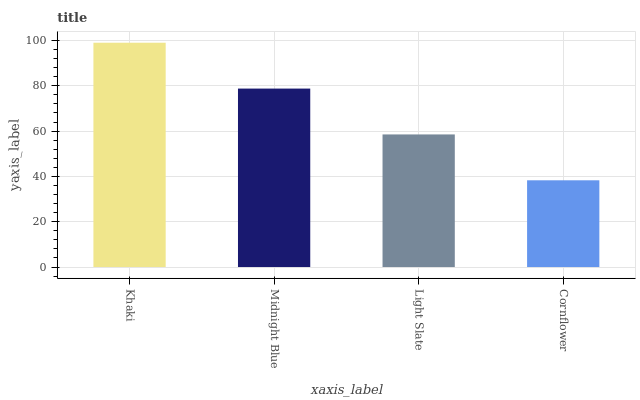Is Cornflower the minimum?
Answer yes or no. Yes. Is Khaki the maximum?
Answer yes or no. Yes. Is Midnight Blue the minimum?
Answer yes or no. No. Is Midnight Blue the maximum?
Answer yes or no. No. Is Khaki greater than Midnight Blue?
Answer yes or no. Yes. Is Midnight Blue less than Khaki?
Answer yes or no. Yes. Is Midnight Blue greater than Khaki?
Answer yes or no. No. Is Khaki less than Midnight Blue?
Answer yes or no. No. Is Midnight Blue the high median?
Answer yes or no. Yes. Is Light Slate the low median?
Answer yes or no. Yes. Is Cornflower the high median?
Answer yes or no. No. Is Cornflower the low median?
Answer yes or no. No. 